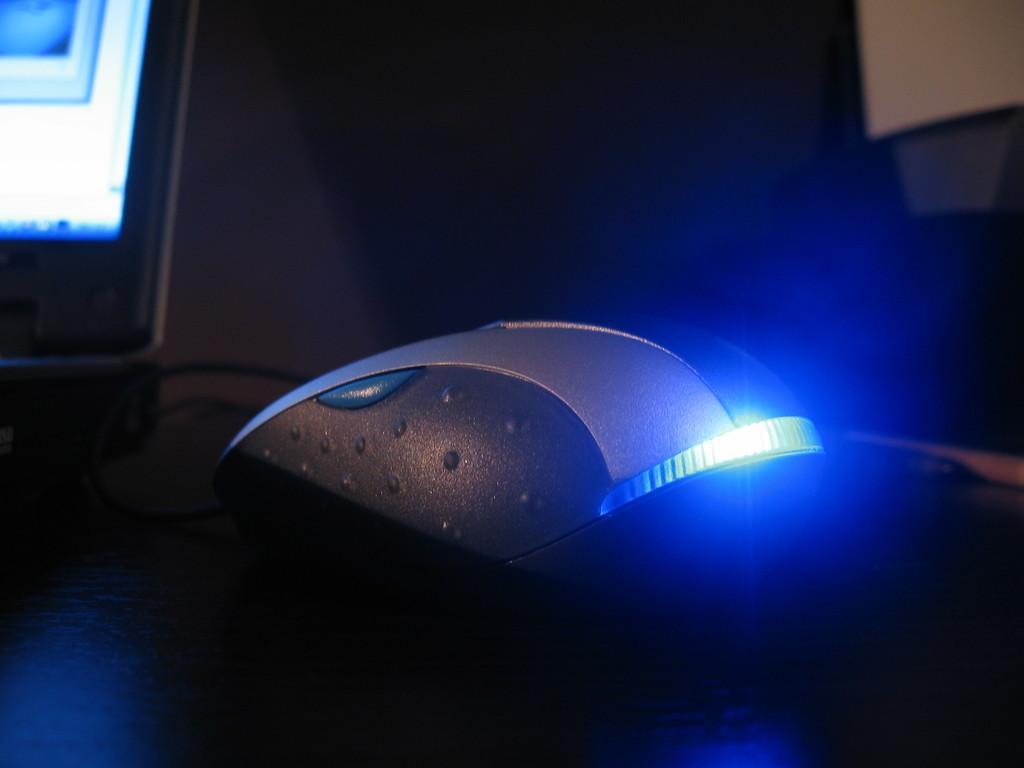Please provide a concise description of this image. There is a mouse kept on the wooden floor in the middle of this image. There is a desktop on the left side of this image and there is a wall in the background. 